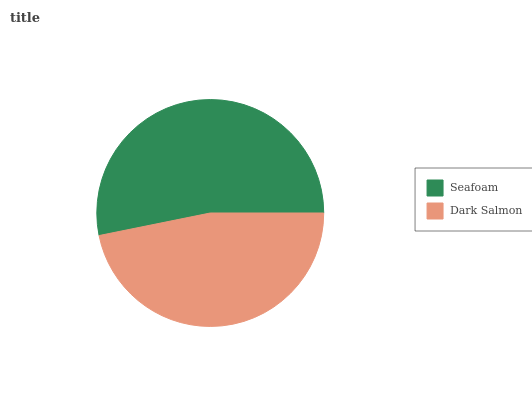Is Dark Salmon the minimum?
Answer yes or no. Yes. Is Seafoam the maximum?
Answer yes or no. Yes. Is Dark Salmon the maximum?
Answer yes or no. No. Is Seafoam greater than Dark Salmon?
Answer yes or no. Yes. Is Dark Salmon less than Seafoam?
Answer yes or no. Yes. Is Dark Salmon greater than Seafoam?
Answer yes or no. No. Is Seafoam less than Dark Salmon?
Answer yes or no. No. Is Seafoam the high median?
Answer yes or no. Yes. Is Dark Salmon the low median?
Answer yes or no. Yes. Is Dark Salmon the high median?
Answer yes or no. No. Is Seafoam the low median?
Answer yes or no. No. 